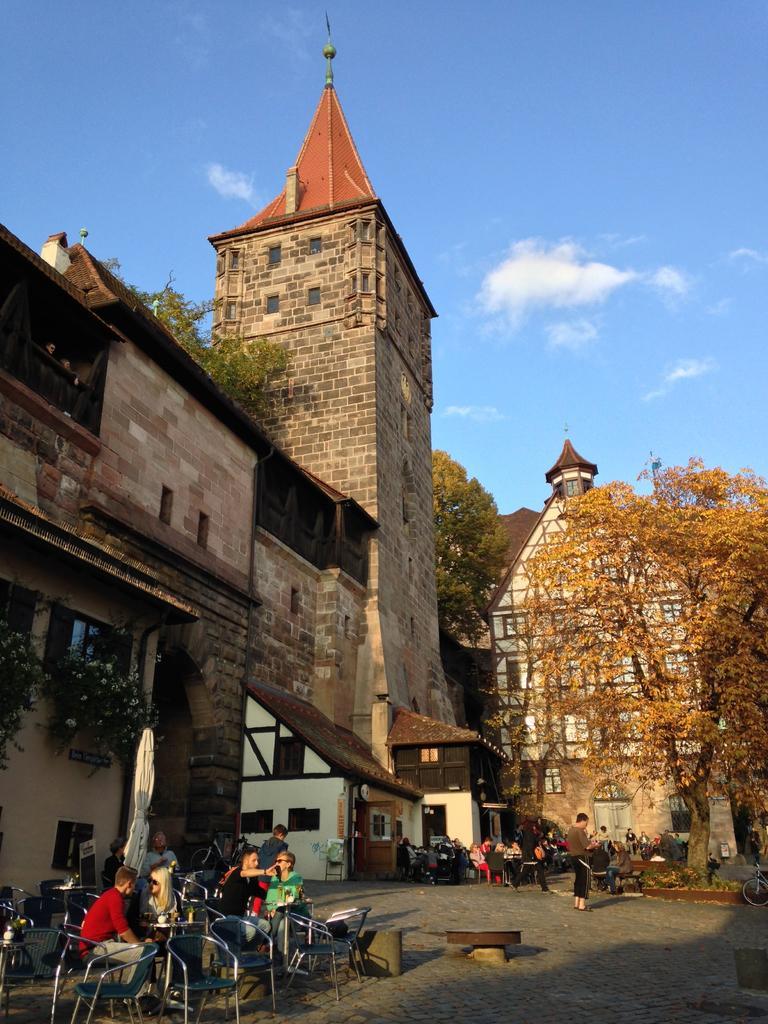Please provide a concise description of this image. In this image, I can see the buildings and trees. At the bottom of the image, I can see groups of people sitting and few people standing. On the left side of the image, there are plants with flowers. In the background, there is the sky. 